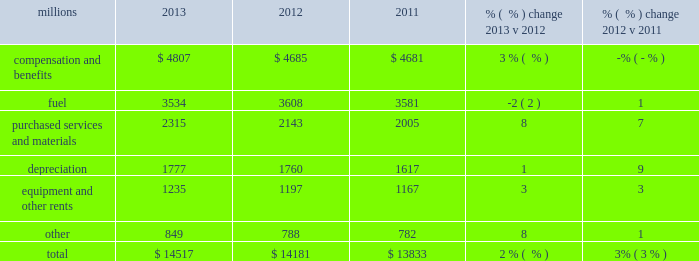Operating expenses millions 2013 2012 2011 % (  % ) change 2013 v 2012 % (  % ) change 2012 v 2011 .
Operating expenses increased $ 336 million in 2013 versus 2012 .
Wage and benefit inflation , new logistics management fees and container costs for our automotive business , locomotive overhauls , property taxes and repairs on jointly owned property contributed to higher expenses during the year .
Lower fuel prices partially offset the cost increases .
Operating expenses increased $ 348 million in 2012 versus 2011 .
Depreciation , wage and benefit inflation , higher fuel prices and volume- related trucking services purchased by our logistics subsidiaries , contributed to higher expenses during the year .
Efficiency gains , volume related fuel savings ( 2% ( 2 % ) fewer gallons of fuel consumed ) and $ 38 million of weather related expenses in 2011 , which favorably affects the comparison , partially offset the cost increase .
Compensation and benefits 2013 compensation and benefits include wages , payroll taxes , health and welfare costs , pension costs , other postretirement benefits , and incentive costs .
General wages and benefits inflation , higher work force levels and increased pension and other postretirement benefits drove the increases in 2013 versus 2012 .
The impact of ongoing productivity initiatives partially offset these increases .
Expenses in 2012 were essentially flat versus 2011 as operational improvements and cost reductions offset general wage and benefit inflation and higher pension and other postretirement benefits .
In addition , weather related costs increased these expenses in 2011 .
Fuel 2013 fuel includes locomotive fuel and gasoline for highway and non-highway vehicles and heavy equipment .
Lower locomotive diesel fuel prices , which averaged $ 3.15 per gallon ( including taxes and transportation costs ) in 2013 , compared to $ 3.22 in 2012 , decreased expenses by $ 75 million .
Volume , as measured by gross ton-miles , decreased 1% ( 1 % ) while the fuel consumption rate , computed as gallons of fuel consumed divided by gross ton-miles , increased 2% ( 2 % ) compared to 2012 .
Declines in heavier , more fuel-efficient coal shipments drove the variances in gross-ton-miles and the fuel consumption rate .
Higher locomotive diesel fuel prices , which averaged $ 3.22 per gallon ( including taxes and transportation costs ) in 2012 , compared to $ 3.12 in 2011 , increased expenses by $ 105 million .
Volume , as measured by gross ton-miles , decreased 2% ( 2 % ) in 2012 versus 2011 , driving expense down .
The fuel consumption rate was flat year-over-year .
Purchased services and materials 2013 expense for purchased services and materials includes the costs of services purchased from outside contractors and other service providers ( including equipment maintenance and contract expenses incurred by our subsidiaries for external transportation services ) ; materials used to maintain the railroad 2019s lines , structures , and equipment ; costs of operating facilities jointly used by uprr and other railroads ; transportation and lodging for train crew employees ; trucking and contracting costs for intermodal containers ; leased automobile maintenance expenses ; and tools and 2013 operating expenses .
What percentage of total operating expenses was fuel in 2013? 
Computations: (3534 / 14517)
Answer: 0.24344. 